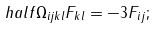Convert formula to latex. <formula><loc_0><loc_0><loc_500><loc_500>\ h a l f \Omega _ { i j k l } F _ { k l } = - 3 F _ { i j } ;</formula> 